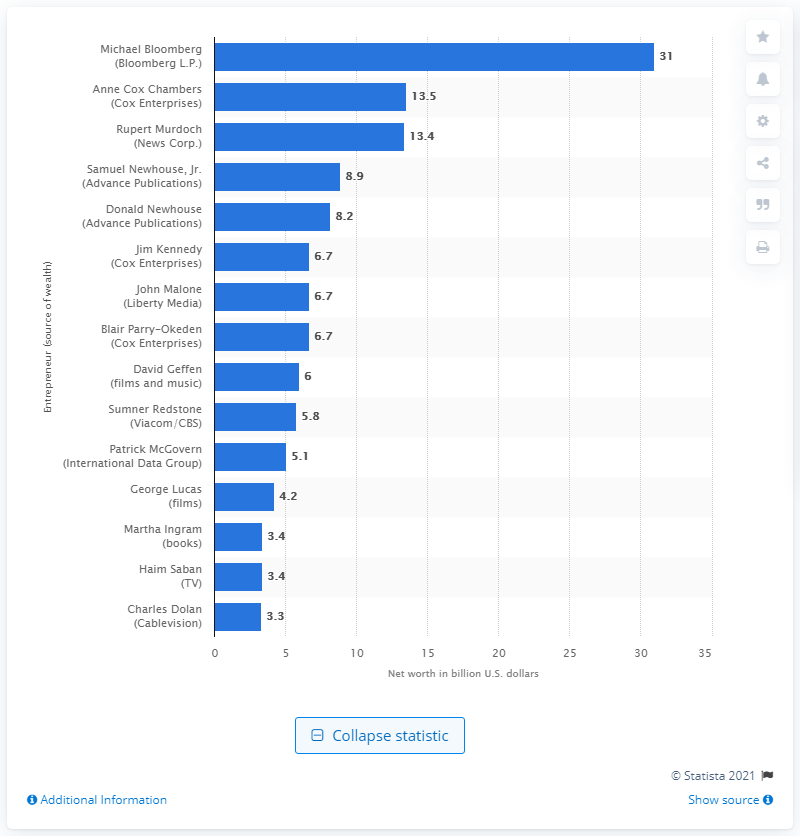Draw attention to some important aspects in this diagram. In 2013, Michael Bloomberg's net worth was $31 billion. 